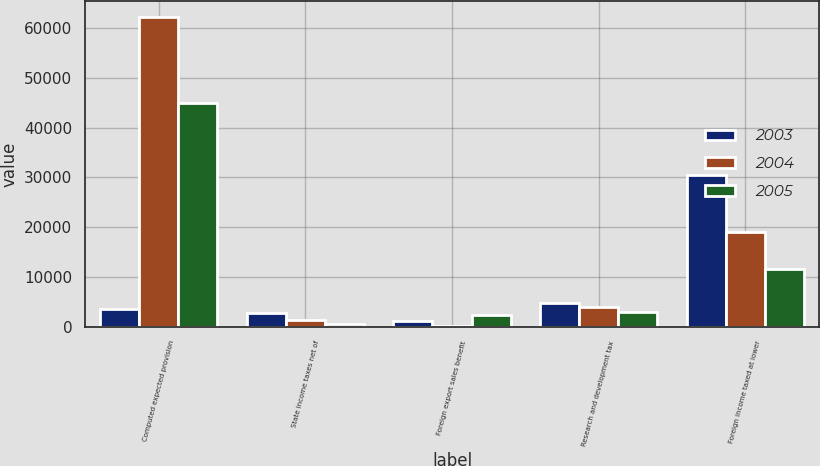Convert chart to OTSL. <chart><loc_0><loc_0><loc_500><loc_500><stacked_bar_chart><ecel><fcel>Computed expected provision<fcel>State income taxes net of<fcel>Foreign export sales benefit<fcel>Research and development tax<fcel>Foreign income taxed at lower<nl><fcel>2003<fcel>3479.5<fcel>2738<fcel>1111<fcel>4750<fcel>30438<nl><fcel>2004<fcel>62264<fcel>1424<fcel>96<fcel>4000<fcel>18958<nl><fcel>2005<fcel>44916<fcel>554<fcel>2278<fcel>2959<fcel>11576<nl></chart> 